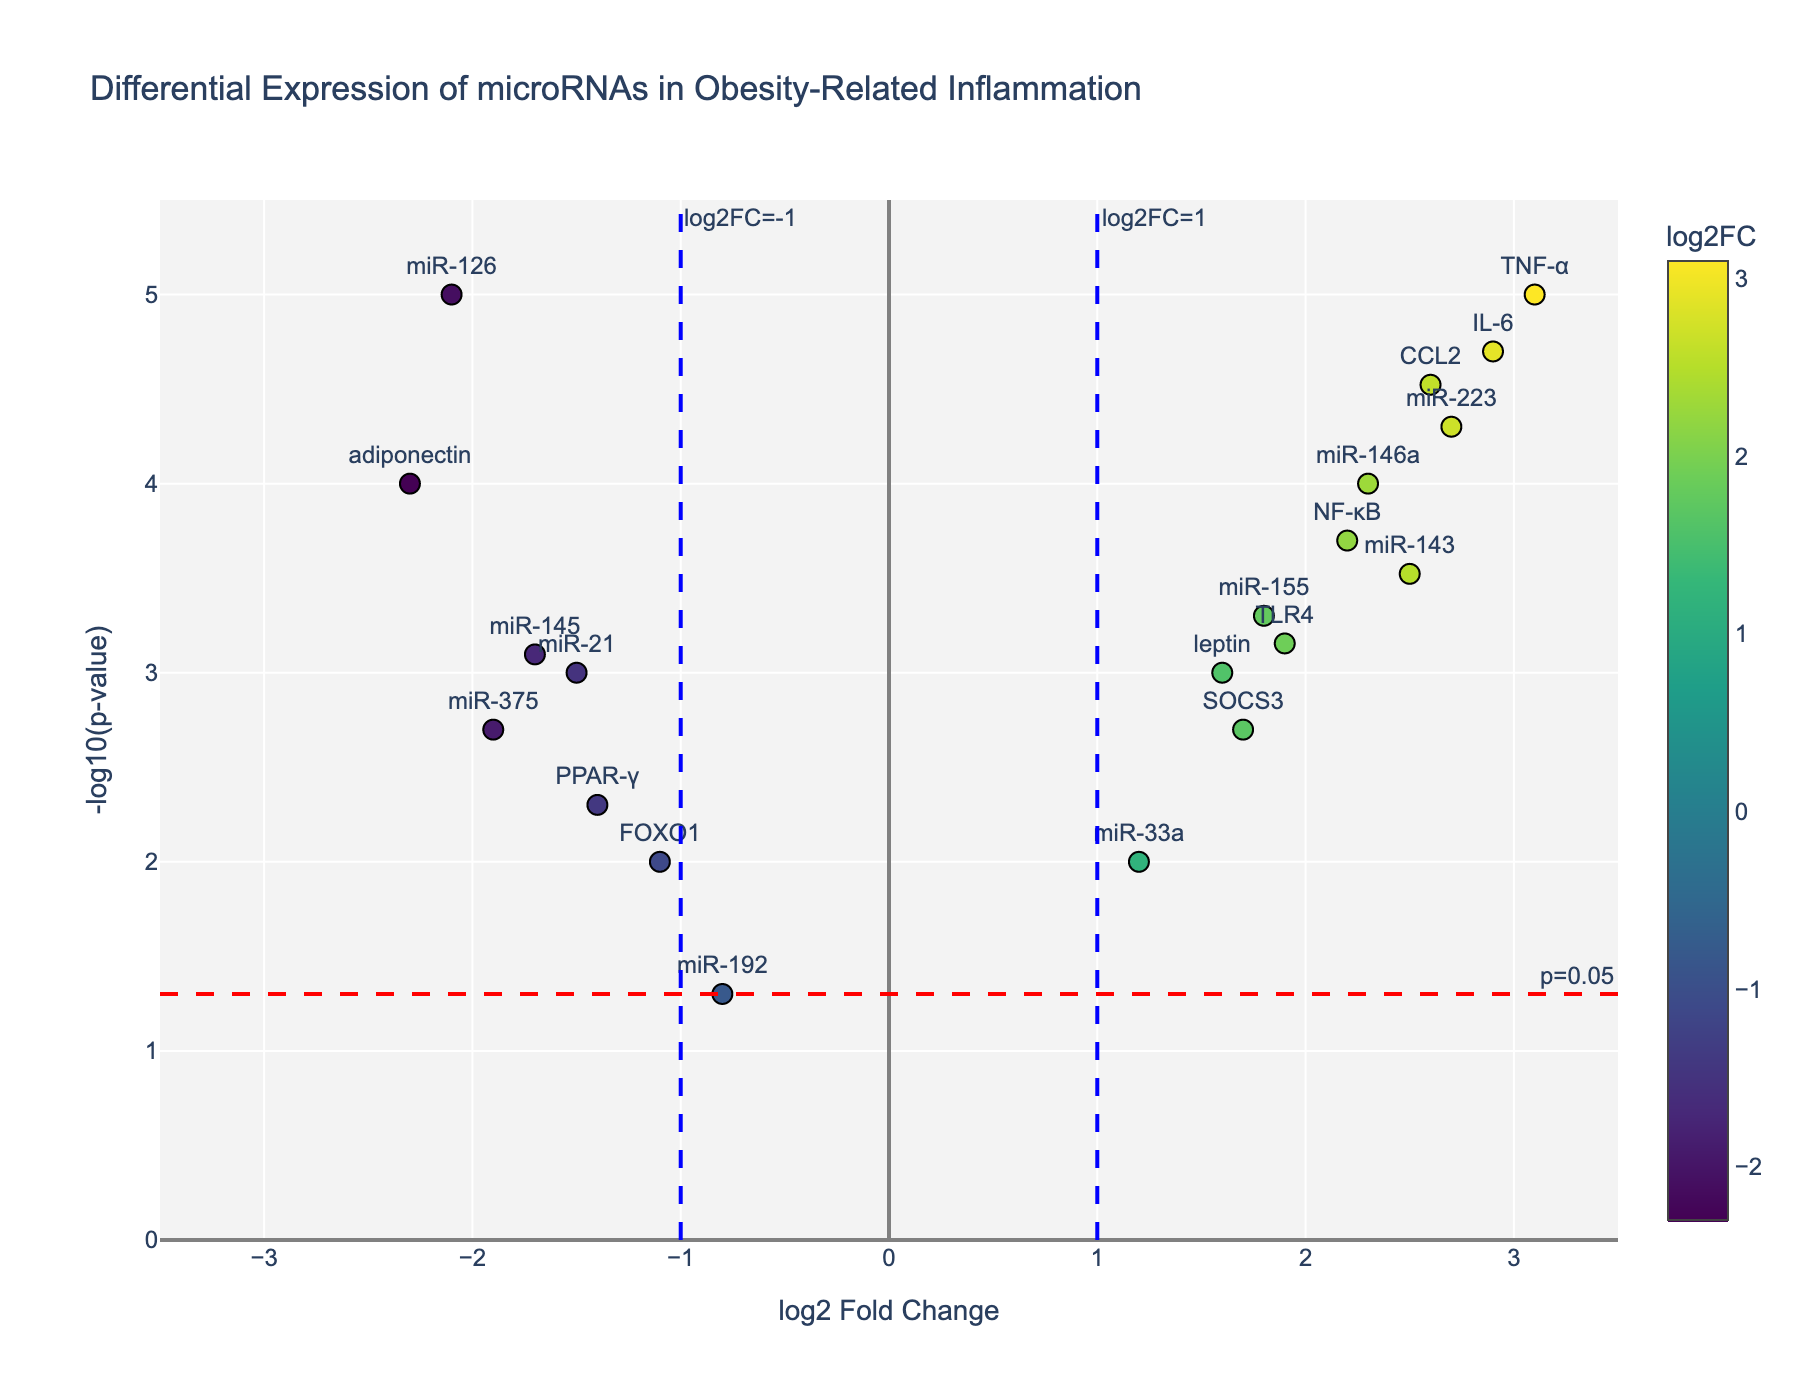What is the title of the figure? The title is located at the top of the figure and reads 'Differential Expression of microRNAs in Obesity-Related Inflammation'.
Answer: 'Differential Expression of microRNAs in Obesity-Related Inflammation' What do the x-axis and y-axis represent? The x-axis represents the log2 Fold Change values, and the y-axis represents the -log10(p-value). These can be determined by looking at the axis labels.
Answer: The x-axis is log2 Fold Change and the y-axis is -log10(p-value) How many genes have a log2 Fold Change greater than 1 and a p-value less than 0.05? From the plot, we can identify data points in the top right quadrant (log2 Fold Change > 1 and -log10(p-value) > -log10(0.05)). Counting these points gives us the answer.
Answer: 8 Which gene has the highest -log10(p-value) and what is its log2 Fold Change? By identifying which data point is located at the highest position on the y-axis, we find that the gene is miR-126 with log2 Fold Change of -2.1.
Answer: miR-126; -2.1 How many genes are downregulated (log2 Fold Change < 0) with statistical significance (p-value < 0.05)? We look for data points in the left half of the plot (log2 Fold Change < 0) that are also above the horizontal line representing p=0.05 (-log10(p-value) > -log10(0.05)). Counting these points provides the answer.
Answer: 5 Compare the log2 Fold Change of miR-146a and TNF-α. Which one is higher and by how much? Find the data points for miR-146a and TNF-α. miR-146a has log2 Fold Change of 2.3, and TNF-α has 3.1. Subtract the values to get the difference.
Answer: TNF-α; 0.8 What is the average log2 Fold Change of the genes miR-155, miR-21, and miR-33a? Sum the log2 Fold Change values of miR-155 (1.8), miR-21 (-1.5), and miR-33a (1.2) and then divide by 3 to get the average.
Answer: 0.5 Which gene has a similar -log10(p-value) as TLR4 but a higher log2 Fold Change? TLR4 has -log10(p-value) around 3.15. Look for a gene with a similar y-axis value but a higher x-axis value (log2 Fold Change). We find that CCL2 fits this criterion.
Answer: CCL2 How many genes exhibit log2 Fold Changes between -1.5 and 1.5? Identify genes within the central part of the plot (between the two vertical lines at log2 FC = -1 and log2 FC = 1). Count these points.
Answer: 5 